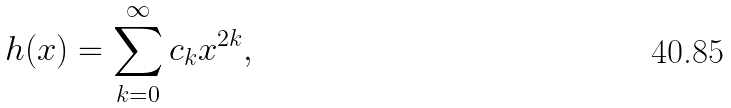Convert formula to latex. <formula><loc_0><loc_0><loc_500><loc_500>h ( x ) = \sum _ { k = 0 } ^ { \infty } c _ { k } x ^ { 2 k } ,</formula> 